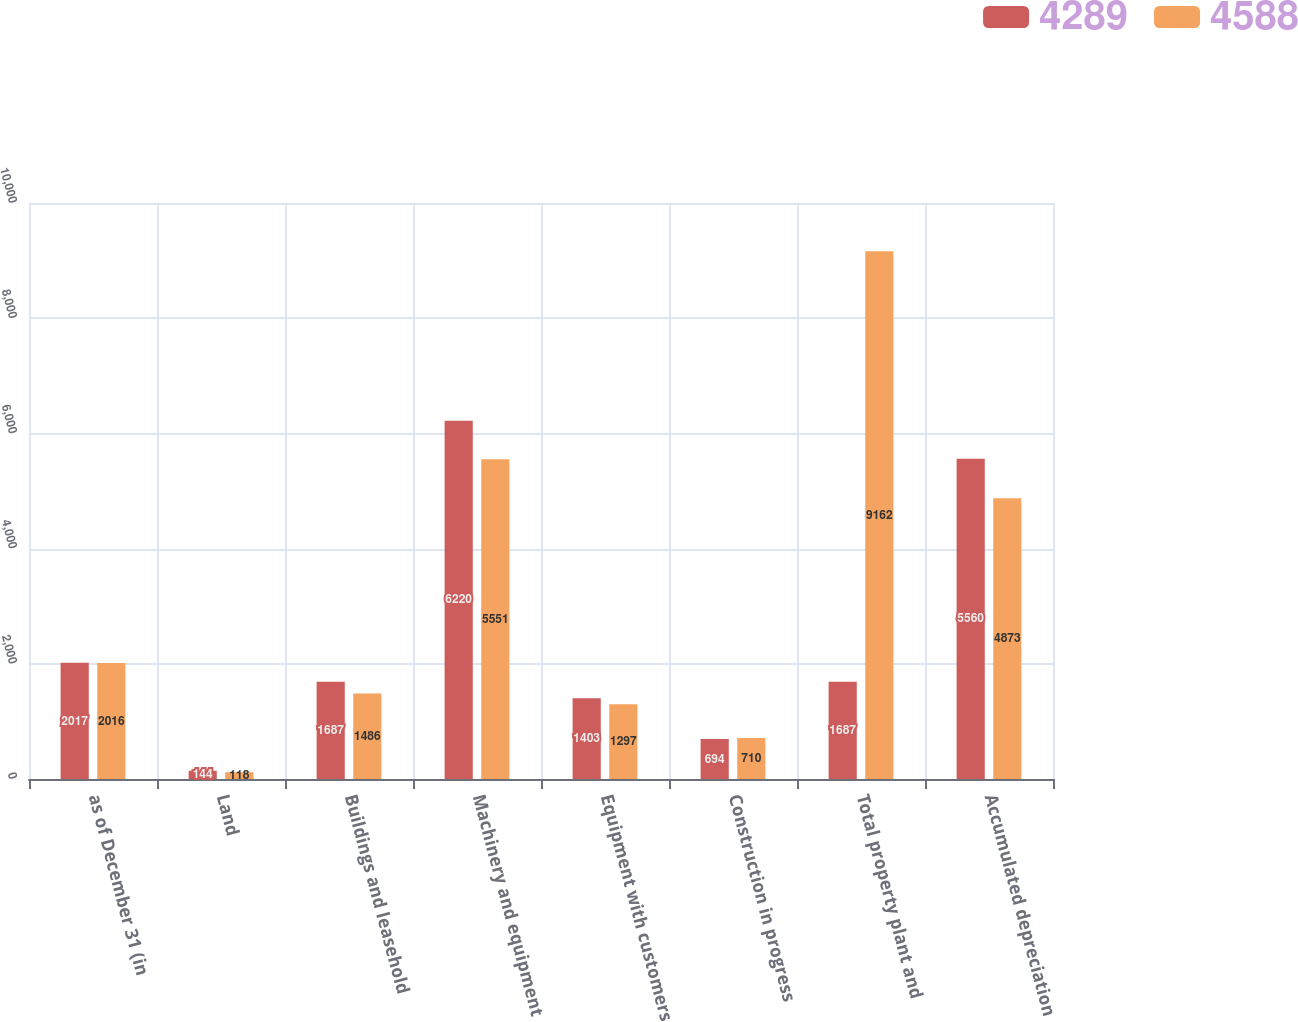Convert chart. <chart><loc_0><loc_0><loc_500><loc_500><stacked_bar_chart><ecel><fcel>as of December 31 (in<fcel>Land<fcel>Buildings and leasehold<fcel>Machinery and equipment<fcel>Equipment with customers<fcel>Construction in progress<fcel>Total property plant and<fcel>Accumulated depreciation<nl><fcel>4289<fcel>2017<fcel>144<fcel>1687<fcel>6220<fcel>1403<fcel>694<fcel>1687<fcel>5560<nl><fcel>4588<fcel>2016<fcel>118<fcel>1486<fcel>5551<fcel>1297<fcel>710<fcel>9162<fcel>4873<nl></chart> 